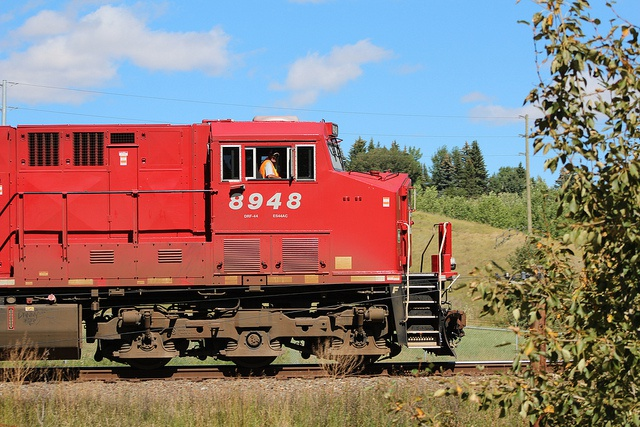Describe the objects in this image and their specific colors. I can see train in lightblue, red, black, salmon, and brown tones and people in lightblue, black, lightgray, orange, and maroon tones in this image. 